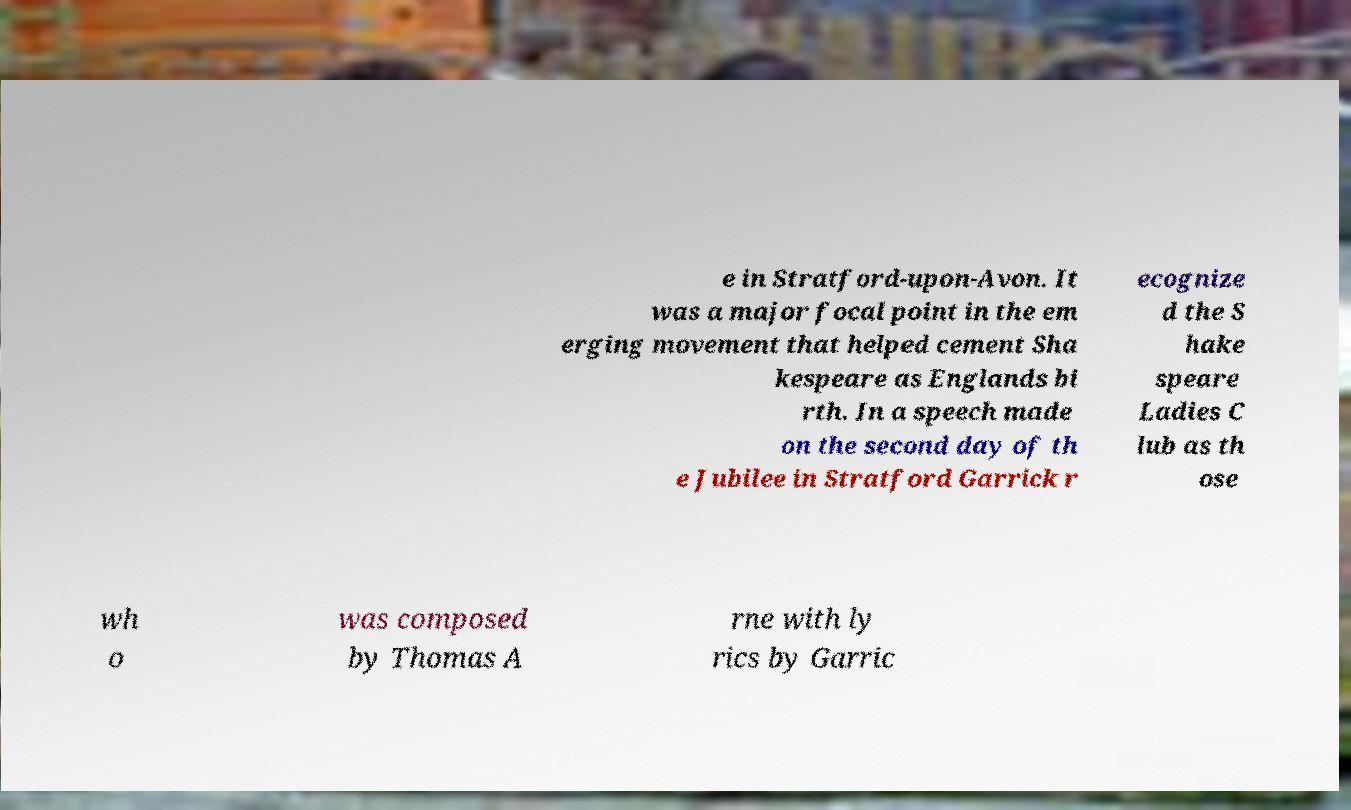Please read and relay the text visible in this image. What does it say? e in Stratford-upon-Avon. It was a major focal point in the em erging movement that helped cement Sha kespeare as Englands bi rth. In a speech made on the second day of th e Jubilee in Stratford Garrick r ecognize d the S hake speare Ladies C lub as th ose wh o was composed by Thomas A rne with ly rics by Garric 